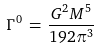<formula> <loc_0><loc_0><loc_500><loc_500>\Gamma ^ { 0 } \, = \, \frac { G ^ { 2 } M ^ { 5 } } { 1 9 2 \pi ^ { 3 } }</formula> 